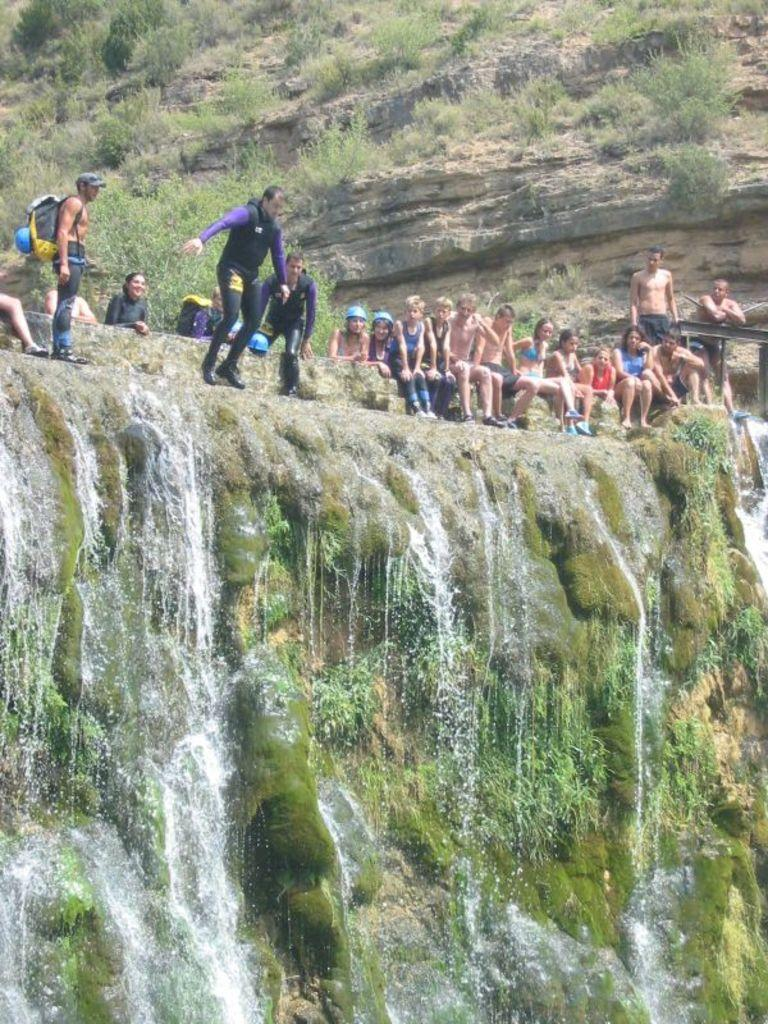What are the people in the image doing? The people in the image are sitting on a rock. What natural feature can be seen in the background of the image? There is a waterfall in the image. What type of vegetation is present in the image? Green grass is visible in the image. What is the main object that the people are sitting on? There is a rock in the image. What type of toy can be seen being played with by the people in the image? There is no toy present in the image; the people are sitting on a rock. Why are the people in the image crying? There is no indication in the image that the people are crying; they are simply sitting on a rock. 